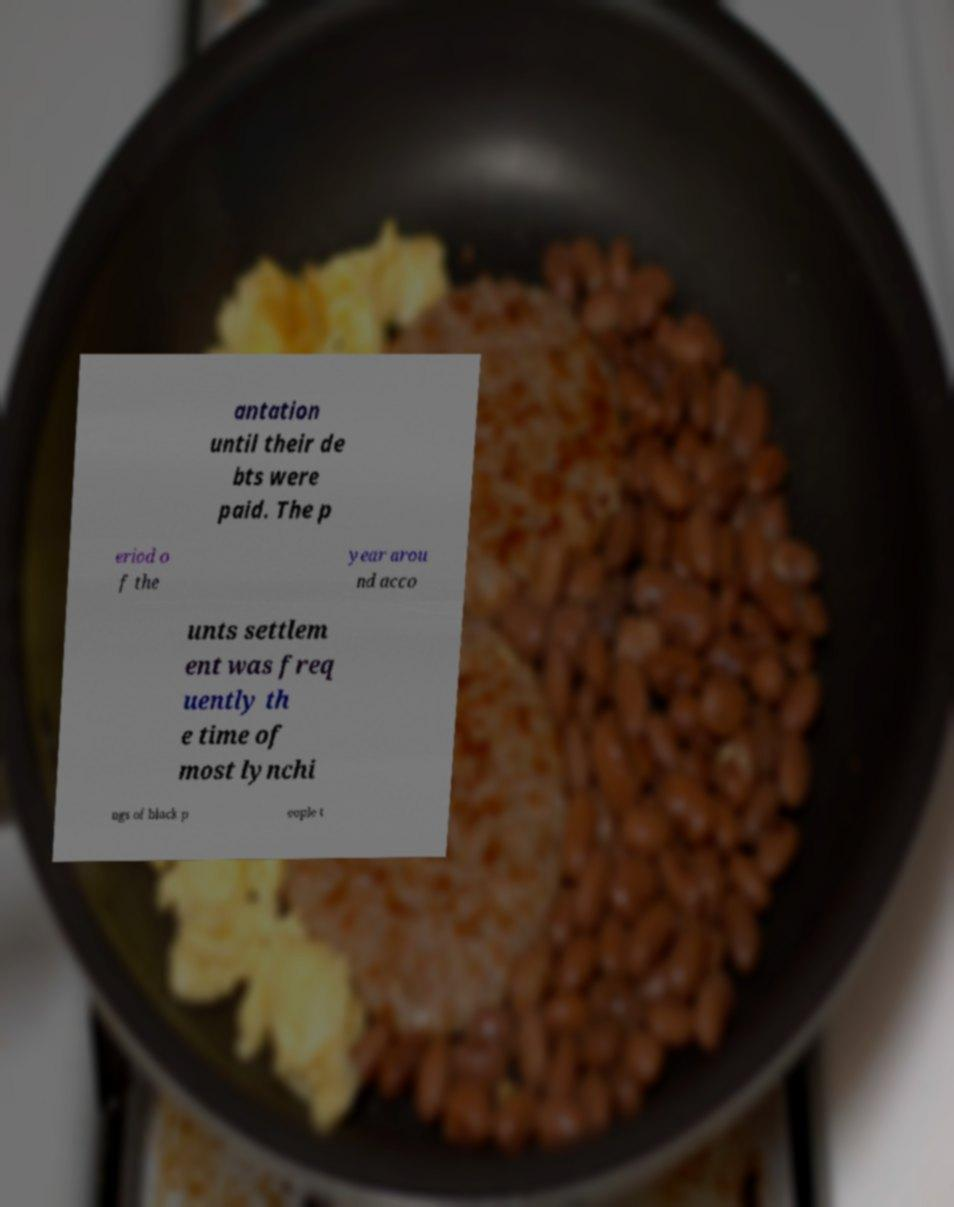Could you extract and type out the text from this image? antation until their de bts were paid. The p eriod o f the year arou nd acco unts settlem ent was freq uently th e time of most lynchi ngs of black p eople t 